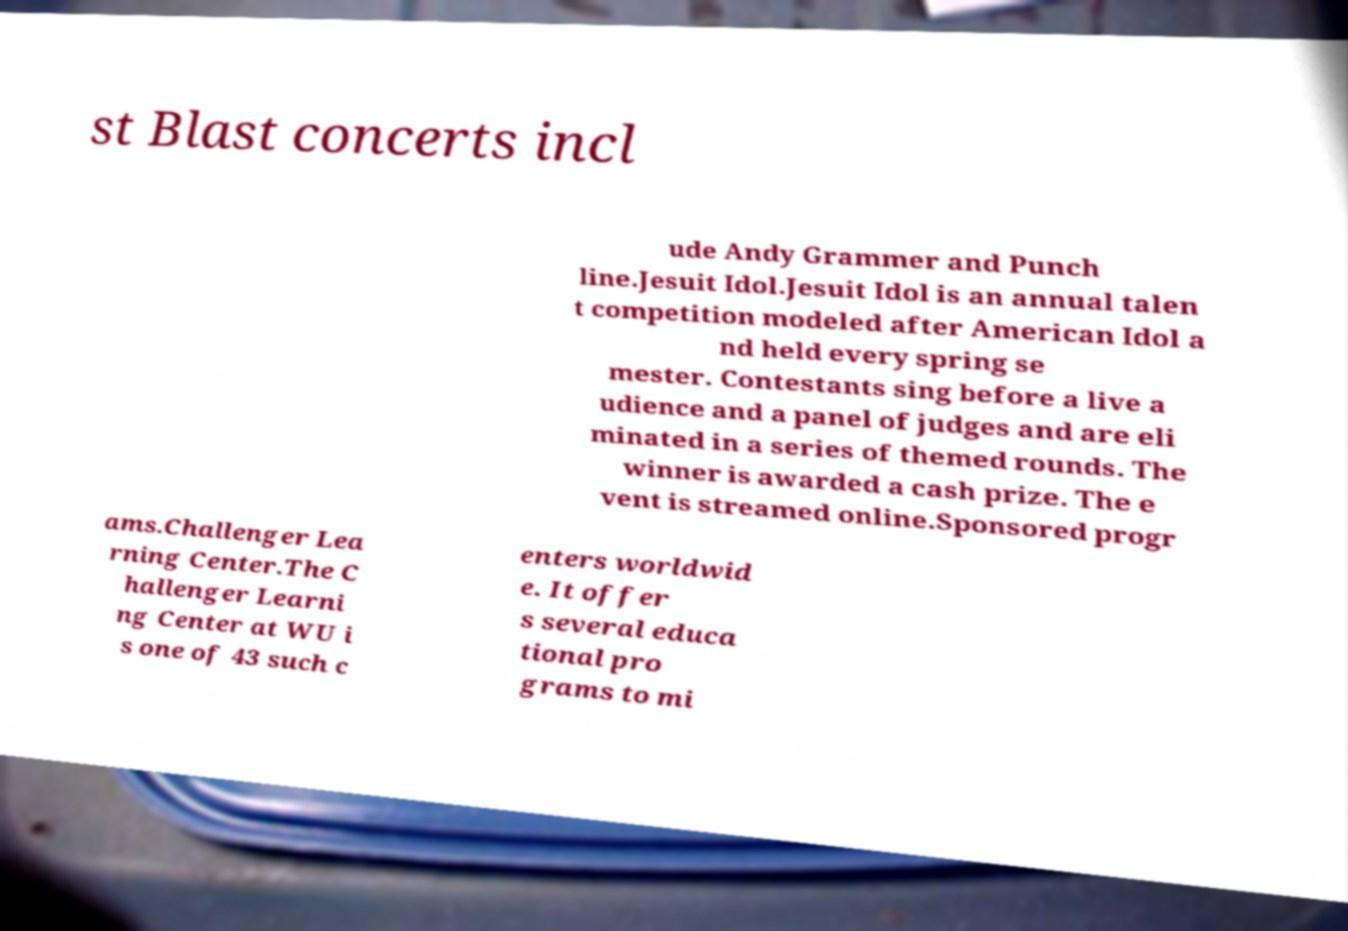For documentation purposes, I need the text within this image transcribed. Could you provide that? st Blast concerts incl ude Andy Grammer and Punch line.Jesuit Idol.Jesuit Idol is an annual talen t competition modeled after American Idol a nd held every spring se mester. Contestants sing before a live a udience and a panel of judges and are eli minated in a series of themed rounds. The winner is awarded a cash prize. The e vent is streamed online.Sponsored progr ams.Challenger Lea rning Center.The C hallenger Learni ng Center at WU i s one of 43 such c enters worldwid e. It offer s several educa tional pro grams to mi 